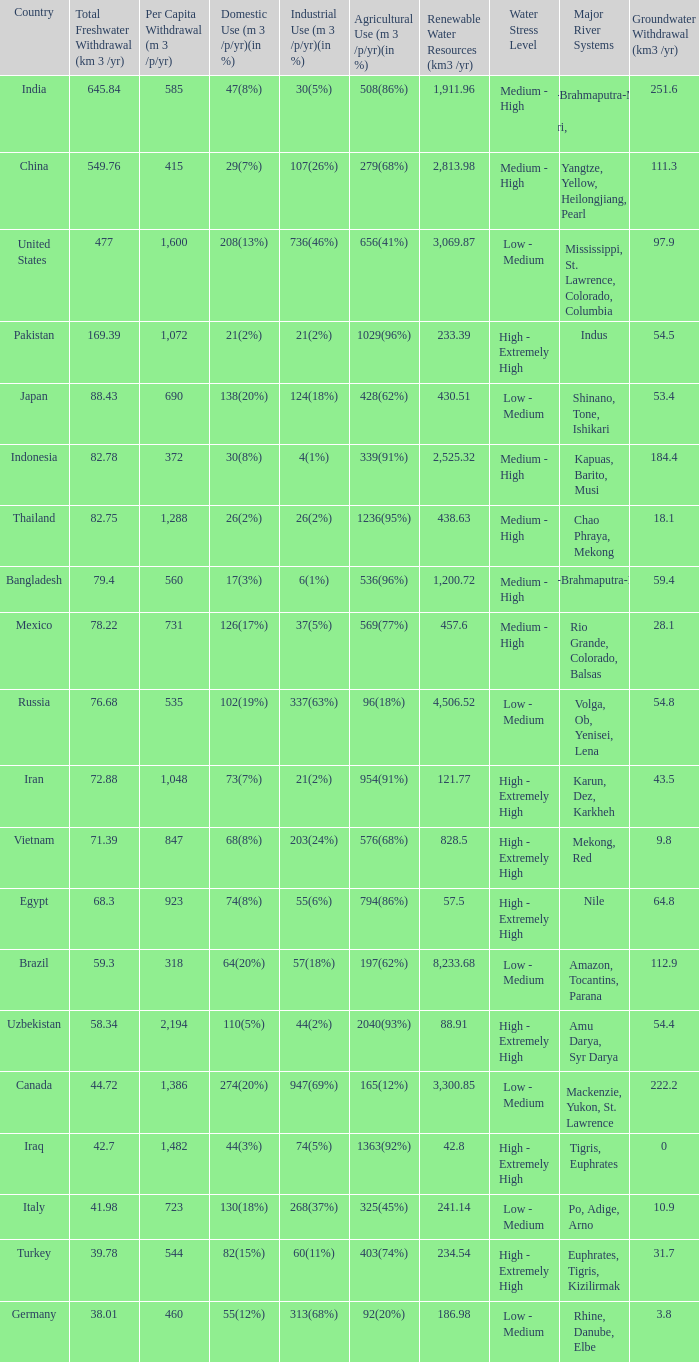What is Agricultural Use (m 3 /p/yr)(in %), when Per Capita Withdrawal (m 3 /p/yr) is greater than 923, and when Domestic Use (m 3 /p/yr)(in %) is 73(7%)? 954(91%). 